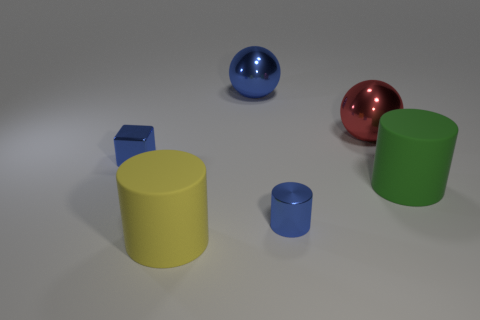Can you describe the texture of the objects? Certainly! The large yellow and small blue cylinders exhibit a matte texture. The metallic cylinder and the red spherical object have a highly reflective, smooth surface, and the green cylinder seems to have a slightly less reflective matte finish compared to the yellow cylinder. 